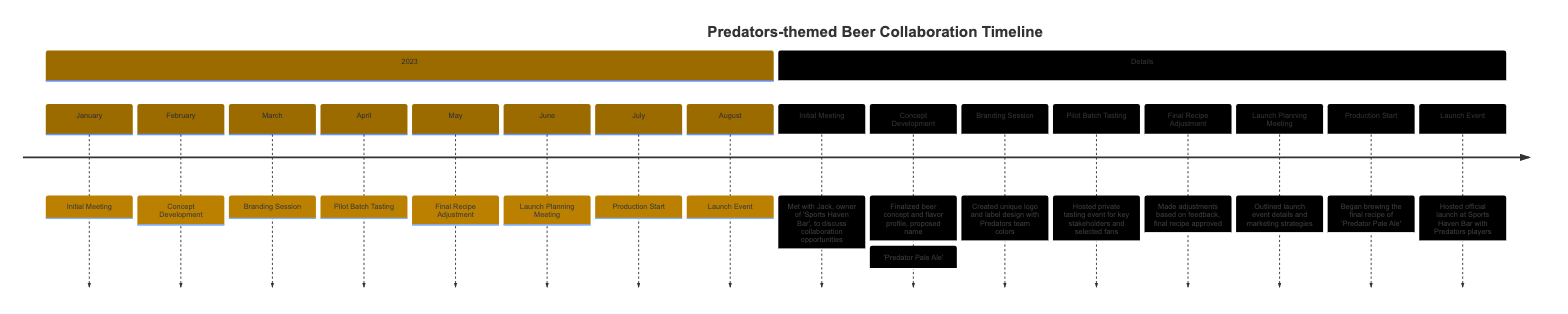What date was the Initial Meeting scheduled? The Initial Meeting is marked in the timeline for the date January 15, 2023. This information is recorded under the "2023" section of the diagram.
Answer: January 15, 2023 What event occurred on March 5, 2023? The event on March 5, 2023, is labeled as "Branding Session." According to the details, this session involved creating a logo and label design.
Answer: Branding Session How many milestones are there in total for the timeline? By counting all the listed events in the timeline, from "Initial Meeting" to "Launch Event," there are a total of 8 milestones.
Answer: 8 What was the proposed name for the beer during the Concept Development? During the Concept Development, the proposed name for the beer was "Predator Pale Ale," as stated in the details.
Answer: Predator Pale Ale Which event followed the Pilot Batch Tasting? Referring to the timeline, the event that followed the Pilot Batch Tasting scheduled in April 2023 is the Final Recipe Adjustment in May 2023.
Answer: Final Recipe Adjustment What color scheme was used for the logo design during the Branding Session? The details indicate that the logo design created during the Branding Session featured Predators team colors, which would typically include navy blue and gold.
Answer: Predators team colors How long was it between the Initial Meeting and the Launch Event? The Initial Meeting occurred on January 15, 2023, and the Launch Event was held on August 5, 2023. The time interval is approximately 7 months and 21 days.
Answer: 7 months and 21 days What was discussed in the Launch Planning Meeting? In the Launch Planning Meeting, they outlined launch event details, marketing strategies, and the distribution plan, focusing on hosting the launch at the Sports Haven Bar.
Answer: Launch details and marketing strategies When did the production of 'Predator Pale Ale' start? The production of 'Predator Pale Ale' began on July 1, 2023, as noted in the timeline.
Answer: July 1, 2023 